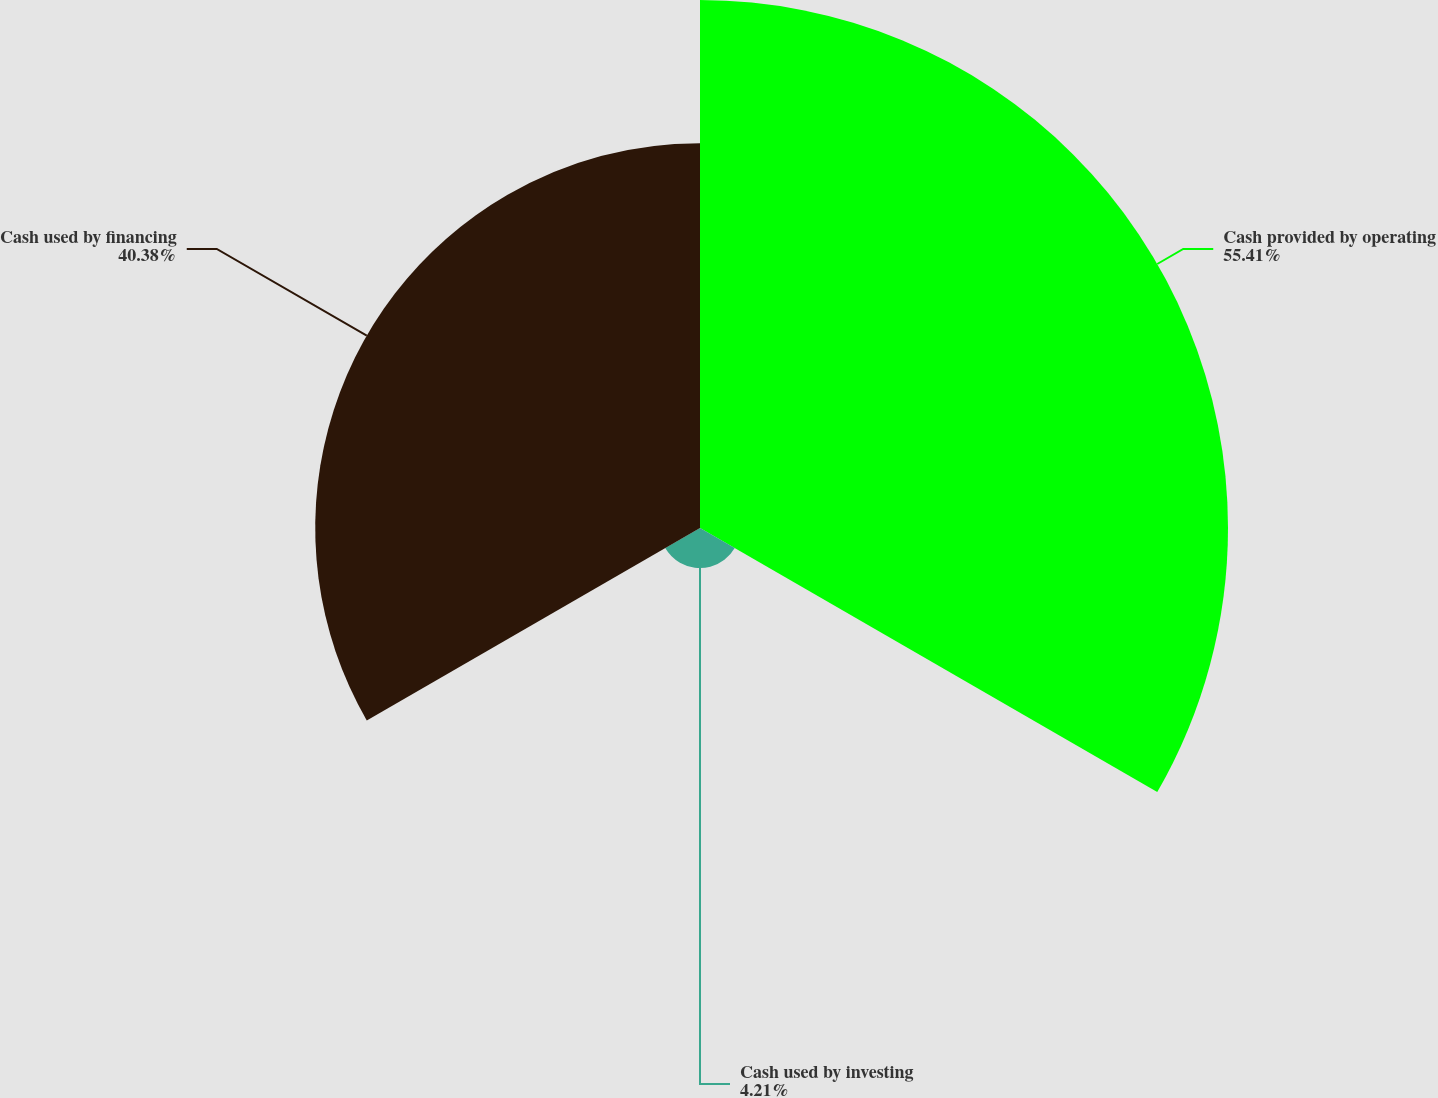<chart> <loc_0><loc_0><loc_500><loc_500><pie_chart><fcel>Cash provided by operating<fcel>Cash used by investing<fcel>Cash used by financing<nl><fcel>55.41%<fcel>4.21%<fcel>40.38%<nl></chart> 